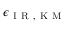<formula> <loc_0><loc_0><loc_500><loc_500>\epsilon _ { I R , K M }</formula> 